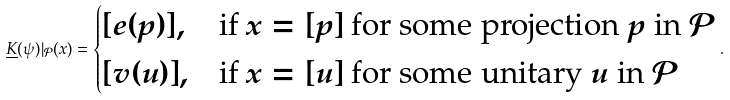Convert formula to latex. <formula><loc_0><loc_0><loc_500><loc_500>\underline { K } ( \psi ) | _ { \mathcal { P } } ( x ) = \begin{cases} [ e ( p ) ] , & \text {if $x = [ p ]$ for some projection $p$ in $\mathcal{P}$} \\ [ v ( u ) ] , & \text {if $x = [ u ]$ for some unitary $u$ in $\mathcal{P}$} \end{cases} .</formula> 